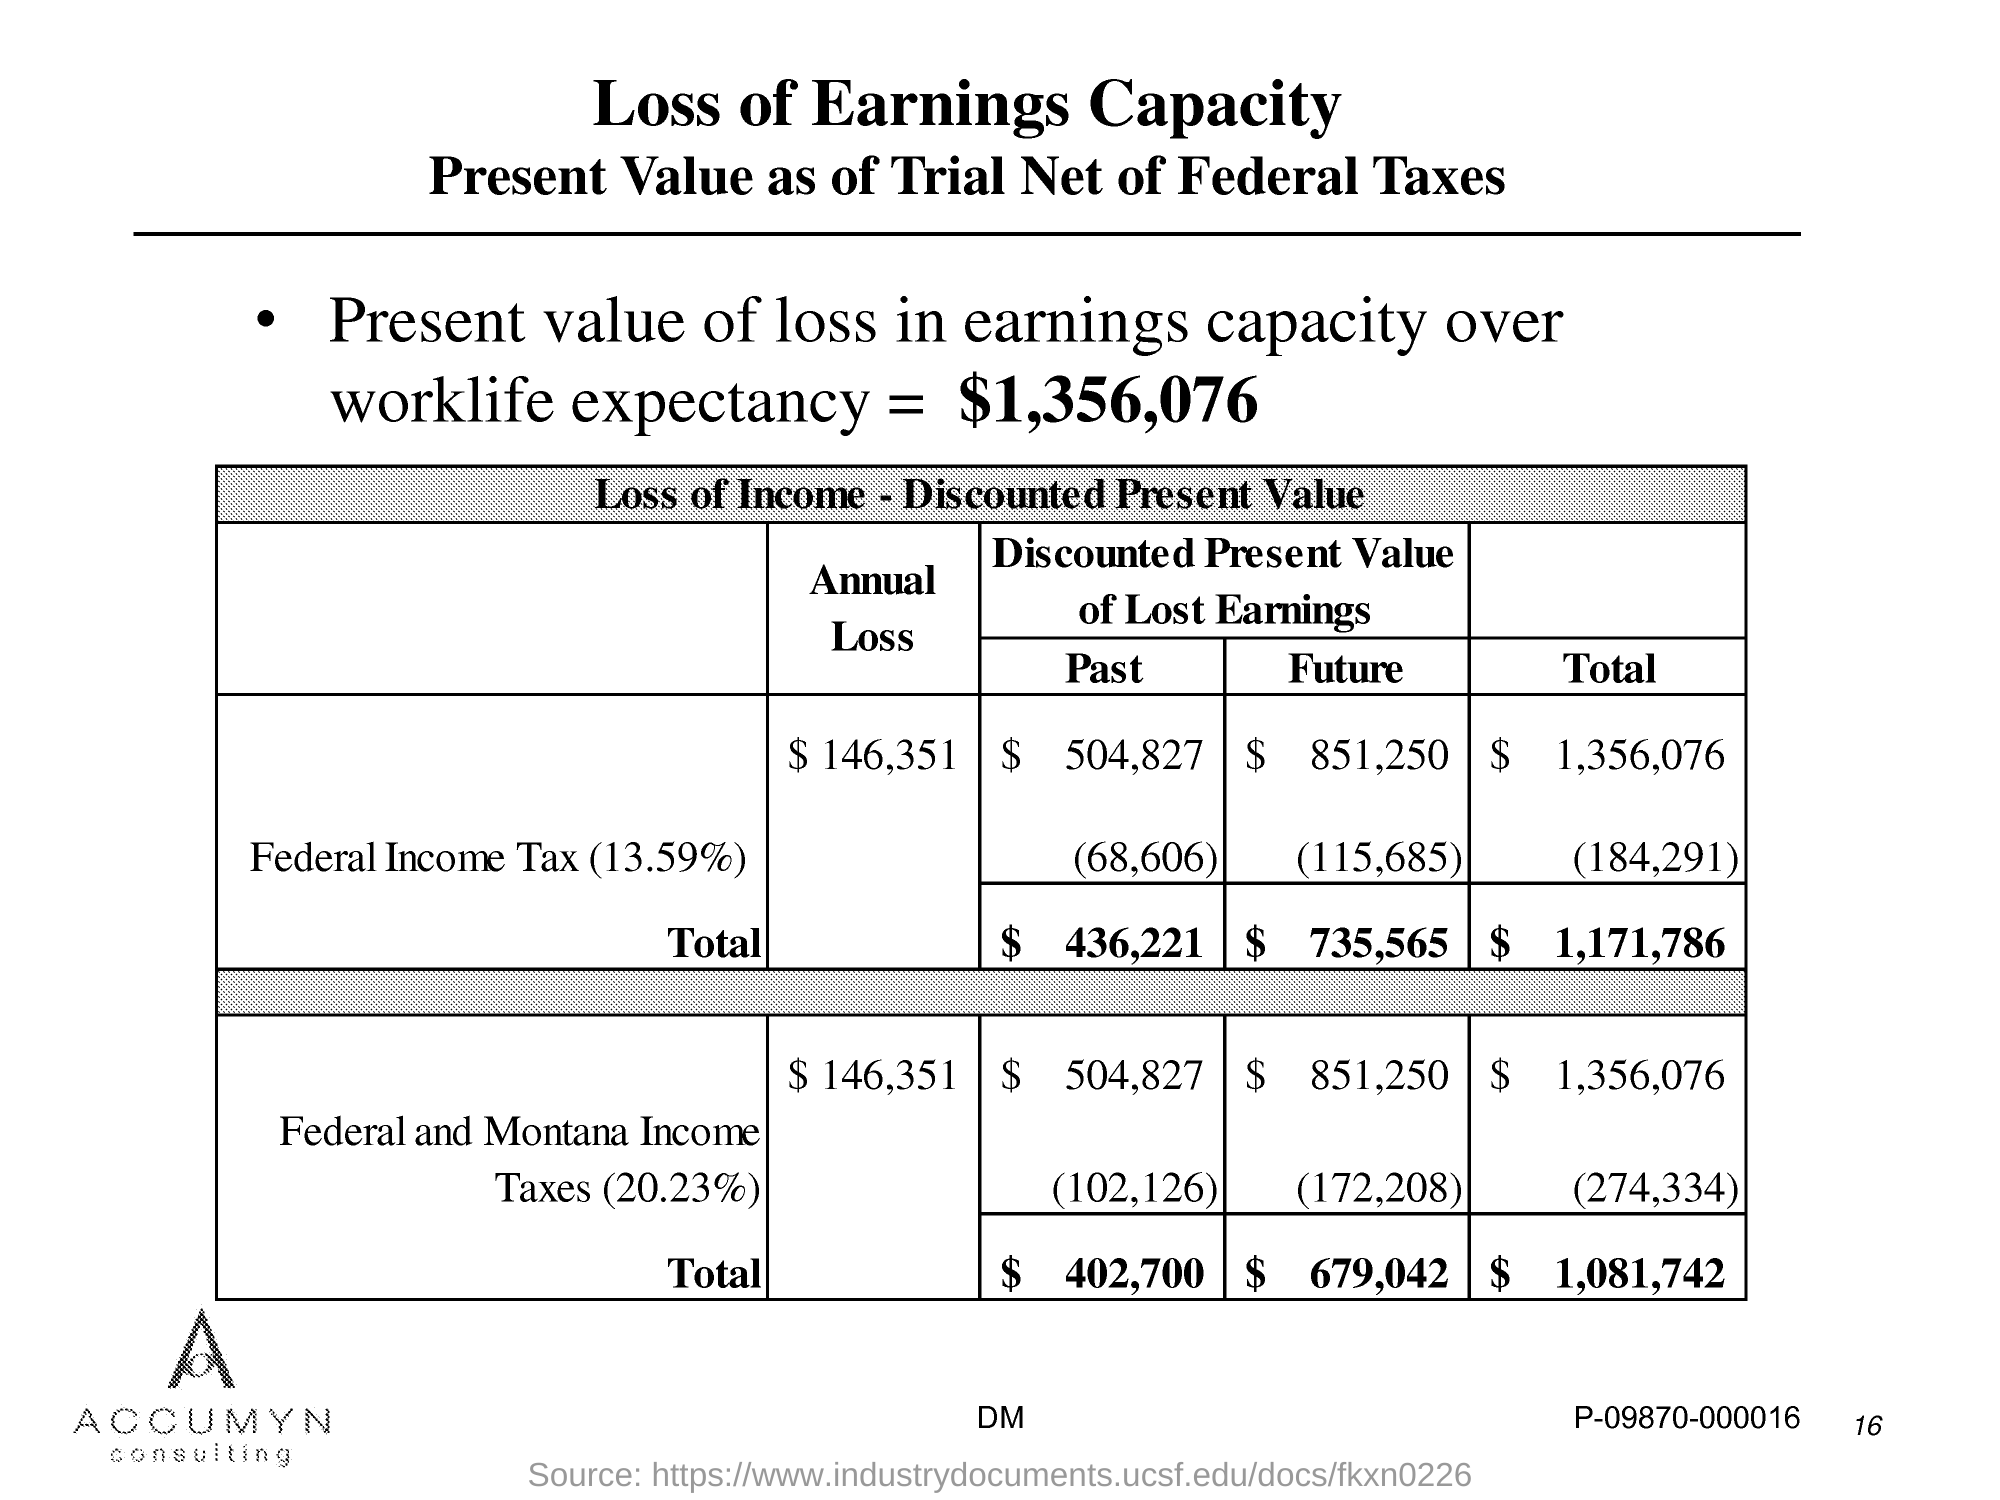Outline some significant characteristics in this image. The present value of loss in earnings capacity over worklife expectancy is estimated to be $1,356,076. 